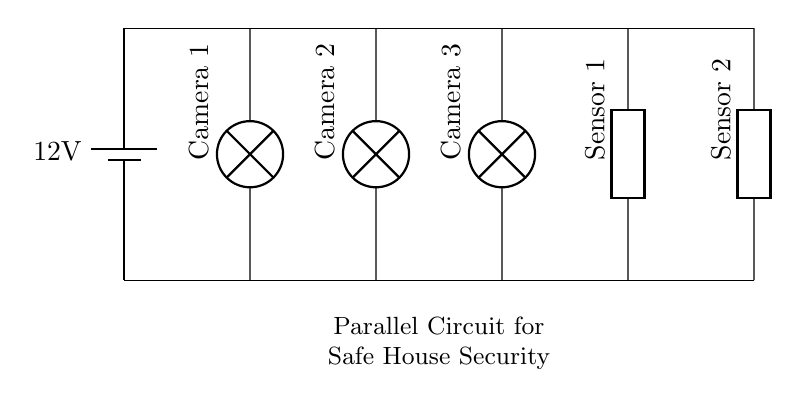What is the voltage provided by the battery? The voltage is written on the battery symbol in the circuit, which indicates a potential difference of 12 volts.
Answer: 12 volts How many security cameras are connected in this circuit? By counting the components labeled as "Camera" in the diagram, we can see that there are three lamps representing the cameras.
Answer: Three What is the type of connection used for the components in this circuit? The components are connected in parallel since each camera and sensor are connected directly to the main voltage lines, allowing them to operate independently.
Answer: Parallel Which component type is used for the motion sensors? The motion sensors are represented by the generic symbol 'generic' in the circuit diagram, indicating a different component type than lamps used for cameras.
Answer: Generic If one camera fails, will the other components continue to function? In parallel circuits, if one component fails, the current can still flow through the other paths, so the remaining cameras and sensors would continue to work.
Answer: Yes How many motion sensors are included in this circuit? There are two components labeled "Sensor" in the diagram, showing that two motion sensors are part of this circuit.
Answer: Two What is the significance of the labels in the circuit diagram? The labels provide clear identification of each component, indicating their function and ensuring understanding of the circuit’s layout and purpose.
Answer: Identification 